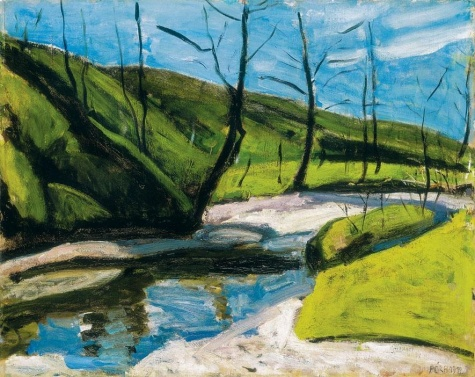Can you describe the techniques used by the artist in this painting? The artist has employed typical impressionist techniques such as loose brushwork and vibrant, unmixed colors to capture the fleeting effects of light and the essence of the scene. Short, thick strokes of paint quickly capture the essence of the subject. The reflection of the sky and trees in the river demonstrates a mastery of light and color, integral to creating the painting's lifelike yet dreamlike quality. 